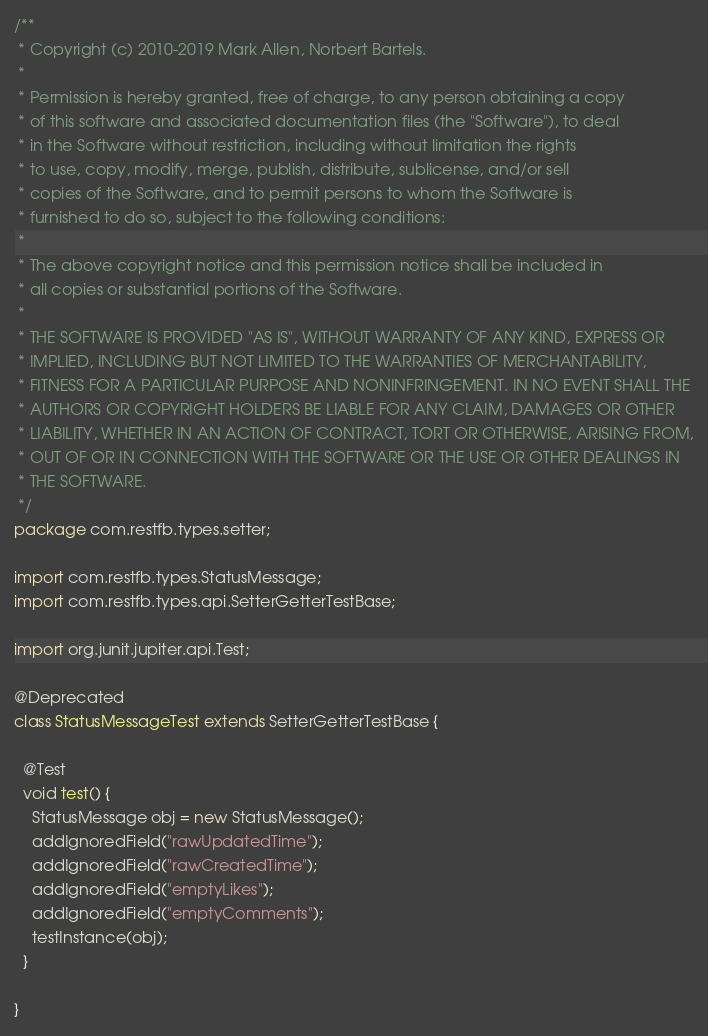<code> <loc_0><loc_0><loc_500><loc_500><_Java_>/**
 * Copyright (c) 2010-2019 Mark Allen, Norbert Bartels.
 *
 * Permission is hereby granted, free of charge, to any person obtaining a copy
 * of this software and associated documentation files (the "Software"), to deal
 * in the Software without restriction, including without limitation the rights
 * to use, copy, modify, merge, publish, distribute, sublicense, and/or sell
 * copies of the Software, and to permit persons to whom the Software is
 * furnished to do so, subject to the following conditions:
 *
 * The above copyright notice and this permission notice shall be included in
 * all copies or substantial portions of the Software.
 *
 * THE SOFTWARE IS PROVIDED "AS IS", WITHOUT WARRANTY OF ANY KIND, EXPRESS OR
 * IMPLIED, INCLUDING BUT NOT LIMITED TO THE WARRANTIES OF MERCHANTABILITY,
 * FITNESS FOR A PARTICULAR PURPOSE AND NONINFRINGEMENT. IN NO EVENT SHALL THE
 * AUTHORS OR COPYRIGHT HOLDERS BE LIABLE FOR ANY CLAIM, DAMAGES OR OTHER
 * LIABILITY, WHETHER IN AN ACTION OF CONTRACT, TORT OR OTHERWISE, ARISING FROM,
 * OUT OF OR IN CONNECTION WITH THE SOFTWARE OR THE USE OR OTHER DEALINGS IN
 * THE SOFTWARE.
 */
package com.restfb.types.setter;

import com.restfb.types.StatusMessage;
import com.restfb.types.api.SetterGetterTestBase;

import org.junit.jupiter.api.Test;

@Deprecated
class StatusMessageTest extends SetterGetterTestBase {

  @Test
  void test() {
    StatusMessage obj = new StatusMessage();
    addIgnoredField("rawUpdatedTime");
    addIgnoredField("rawCreatedTime");
    addIgnoredField("emptyLikes");
    addIgnoredField("emptyComments");
    testInstance(obj);
  }

}
</code> 